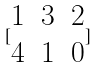Convert formula to latex. <formula><loc_0><loc_0><loc_500><loc_500>[ \begin{matrix} 1 & 3 & 2 \\ 4 & 1 & 0 \end{matrix} ]</formula> 